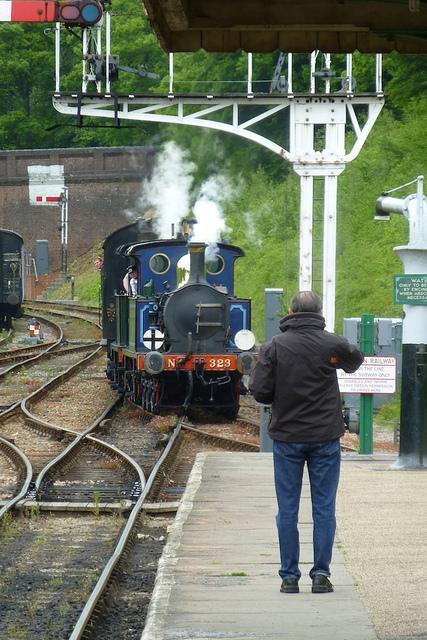Why are the people travelling on the train?
Select the accurate response from the four choices given to answer the question.
Options: Eating food, learning driving, commuting, touring. Touring. 